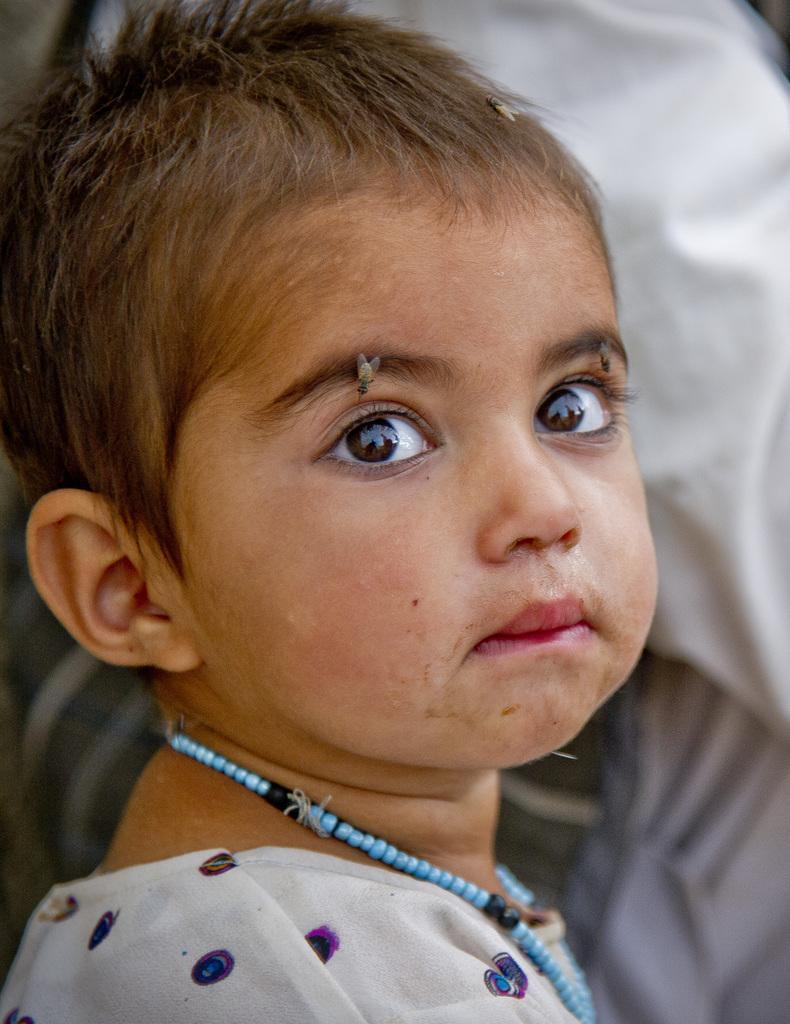Could you give a brief overview of what you see in this image? There are two flies on the eyebrow and one fly on the head of a baby who is wearing a beaded necklace. In the background, there is white color cloth. 